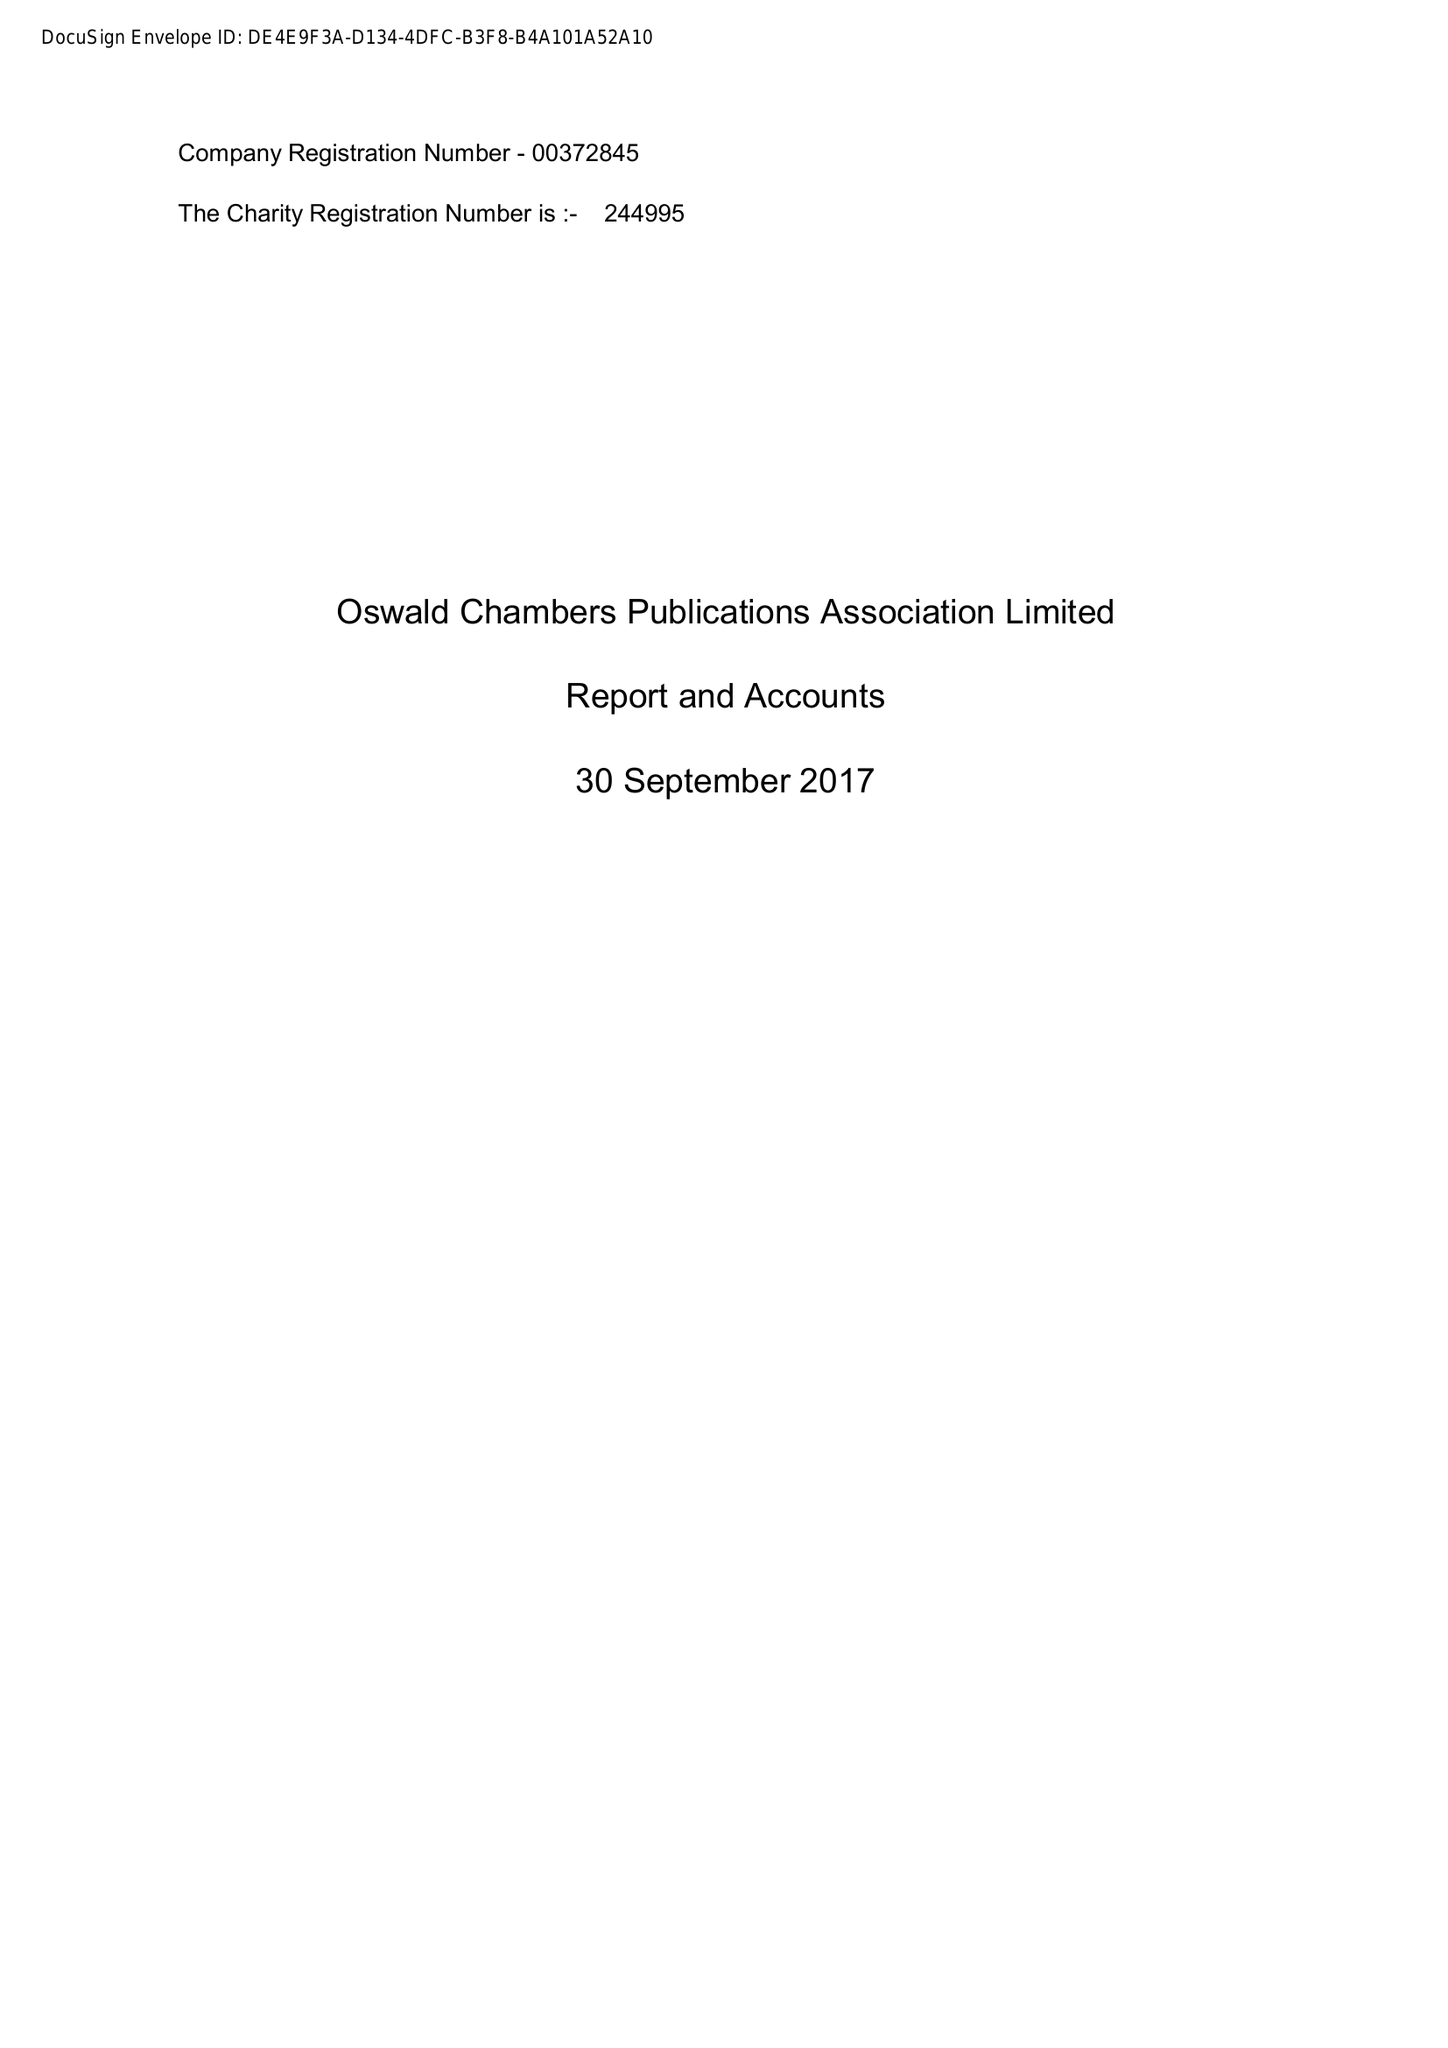What is the value for the address__post_town?
Answer the question using a single word or phrase. CREWE 